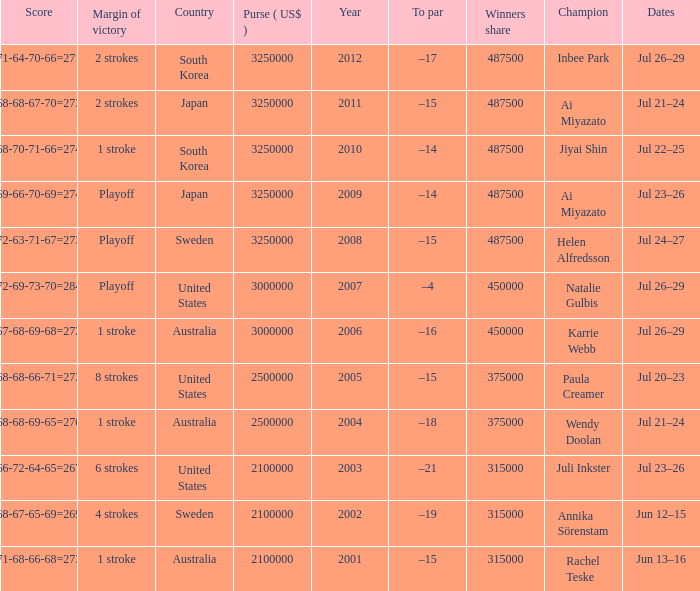How many years was Jiyai Shin the champion? 1.0. 